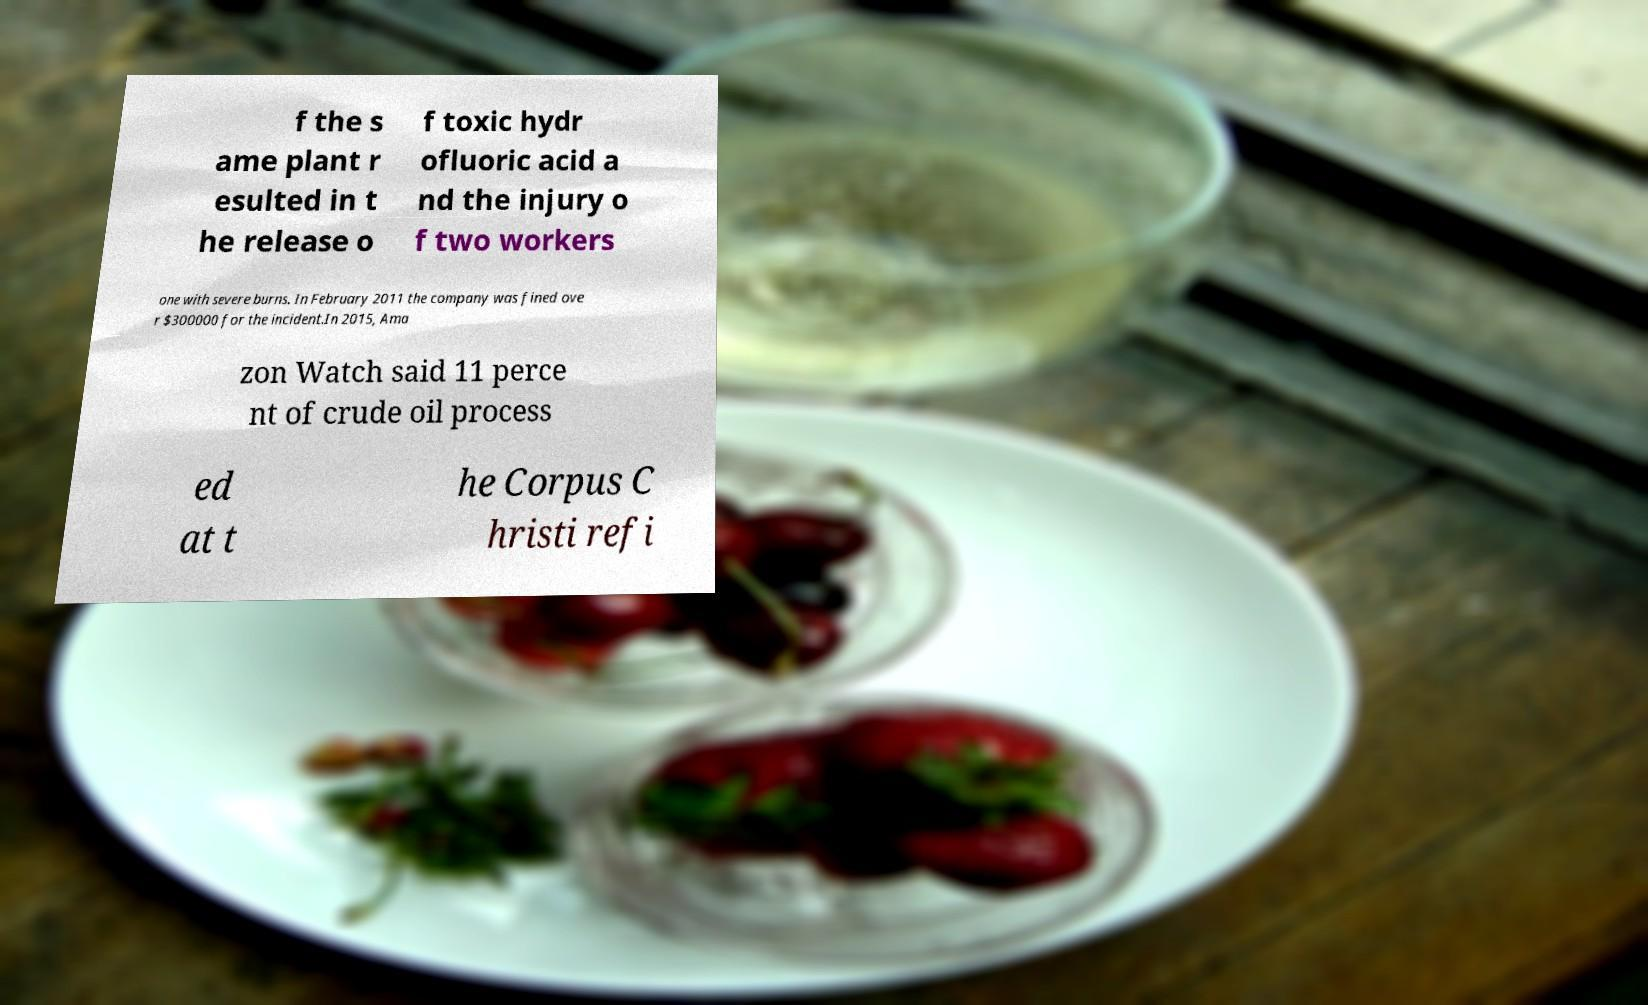For documentation purposes, I need the text within this image transcribed. Could you provide that? f the s ame plant r esulted in t he release o f toxic hydr ofluoric acid a nd the injury o f two workers one with severe burns. In February 2011 the company was fined ove r $300000 for the incident.In 2015, Ama zon Watch said 11 perce nt of crude oil process ed at t he Corpus C hristi refi 